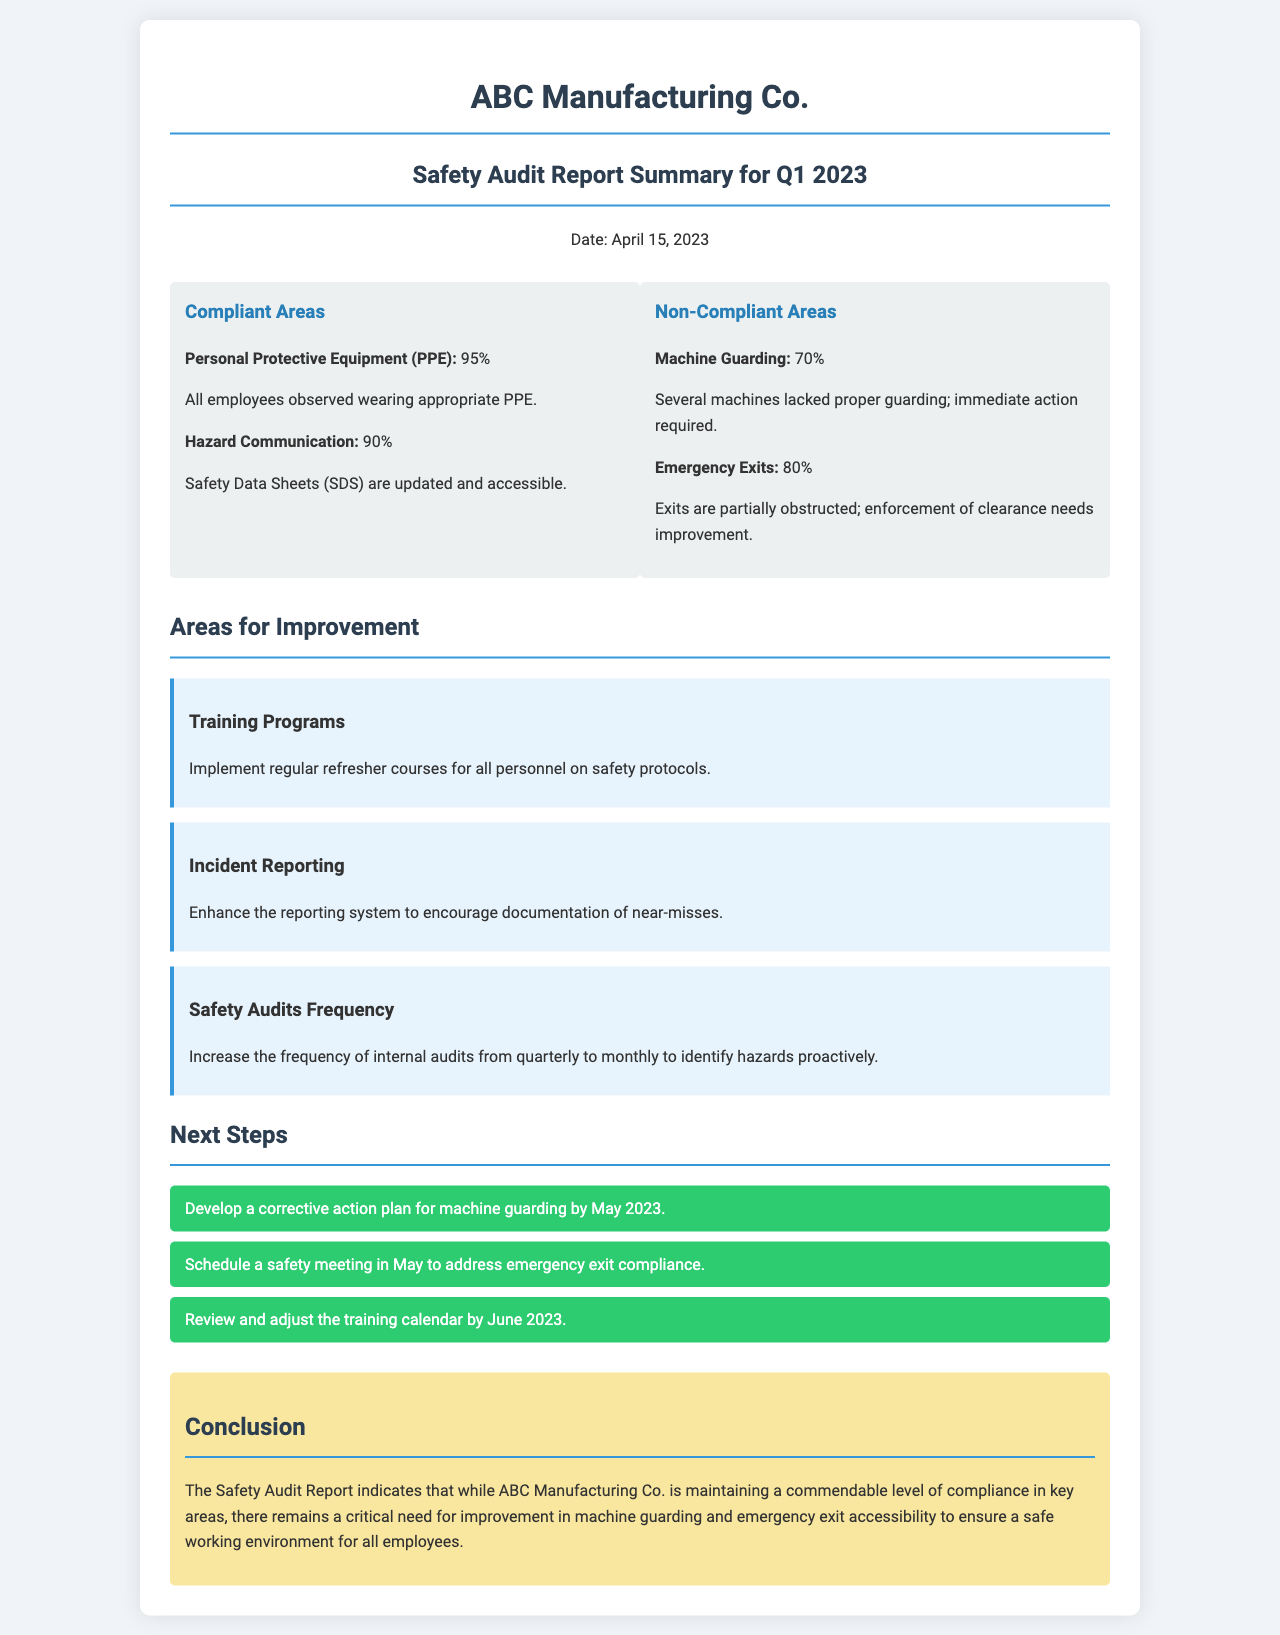What is the date of the report? The report is dated April 15, 2023, as mentioned in the header.
Answer: April 15, 2023 What percentage of employees were observed wearing appropriate PPE? The compliant area indicates that 95% of employees were observed wearing appropriate PPE.
Answer: 95% Which area is identified as non-compliant with the lowest percentage? The non-compliant area shows that Machine Guarding is at 70%, making it the lowest compliance percentage.
Answer: 70% What training program improvement is suggested? The document suggests implementing regular refresher courses for all personnel on safety protocols.
Answer: Regular refresher courses What is one of the next steps mentioned? The next steps include developing a corrective action plan for machine guarding by May 2023.
Answer: Develop a corrective action plan for machine guarding by May 2023 What is the compliance percentage for Hazard Communication? The compliance status indicates that Hazard Communication is at 90%.
Answer: 90% How frequently should internal audits be increased? The document recommends increasing the frequency of audits from quarterly to monthly.
Answer: Monthly What is a critical need for improvement identified in the conclusion? The conclusion indicates a critical need for improvement in machine guarding and emergency exit accessibility.
Answer: Machine guarding and emergency exit accessibility 